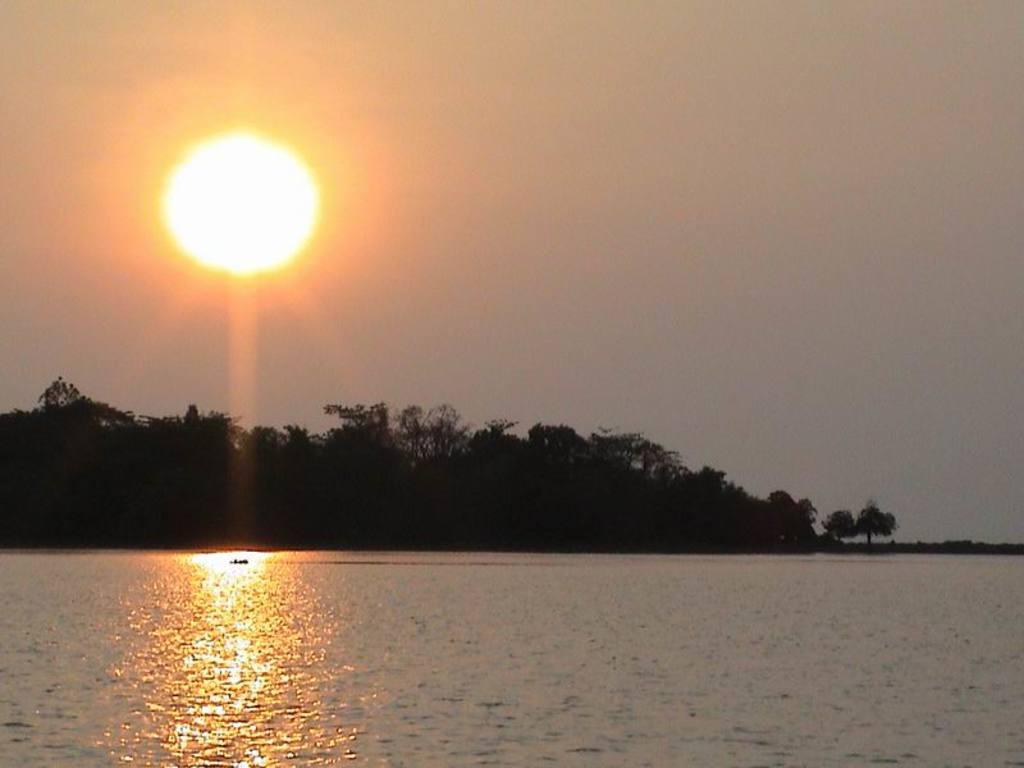Please provide a concise description of this image. At the bottom of the picture, we see water ad this water might be in the river. There are trees in the background. At the top, we see the sky and the sun. 